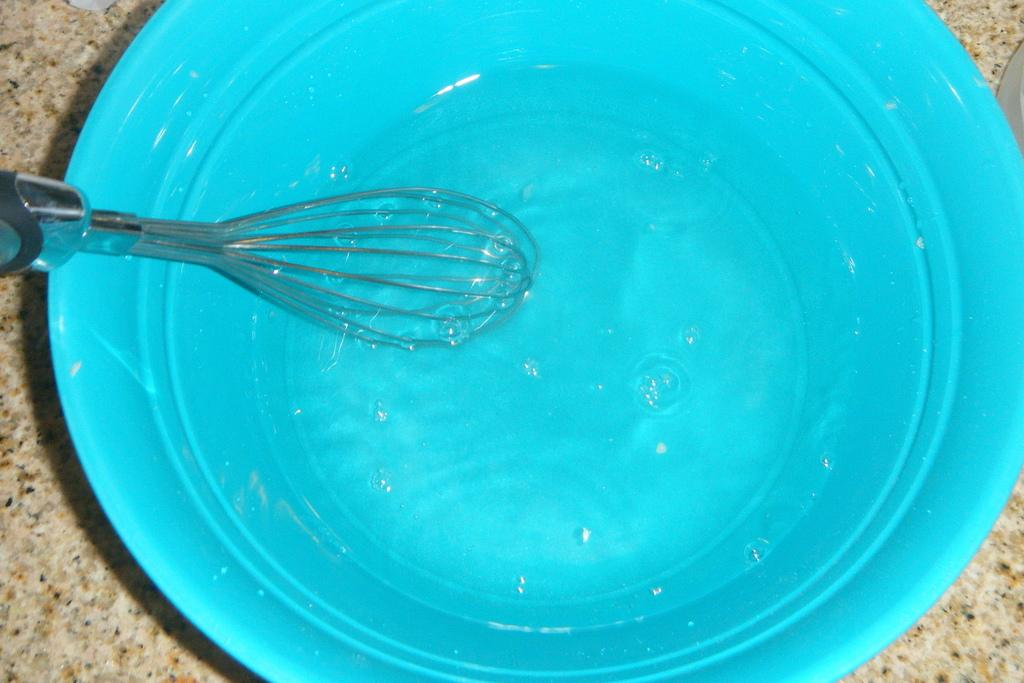What object is present in the image that is used for mixing or blending? There is a whisker in the image. What is contained in the blue bucket in the image? There is water in a blue bucket in the image. Where is the blue bucket located in the image? The blue bucket is kept on the floor. What type of stone can be seen on the left side of the image? There is a granite stone on the left side of the image. What flavor of ice cream is being served with the rake in the yard? There is no ice cream or rake present in the image, nor is there a yard depicted. 